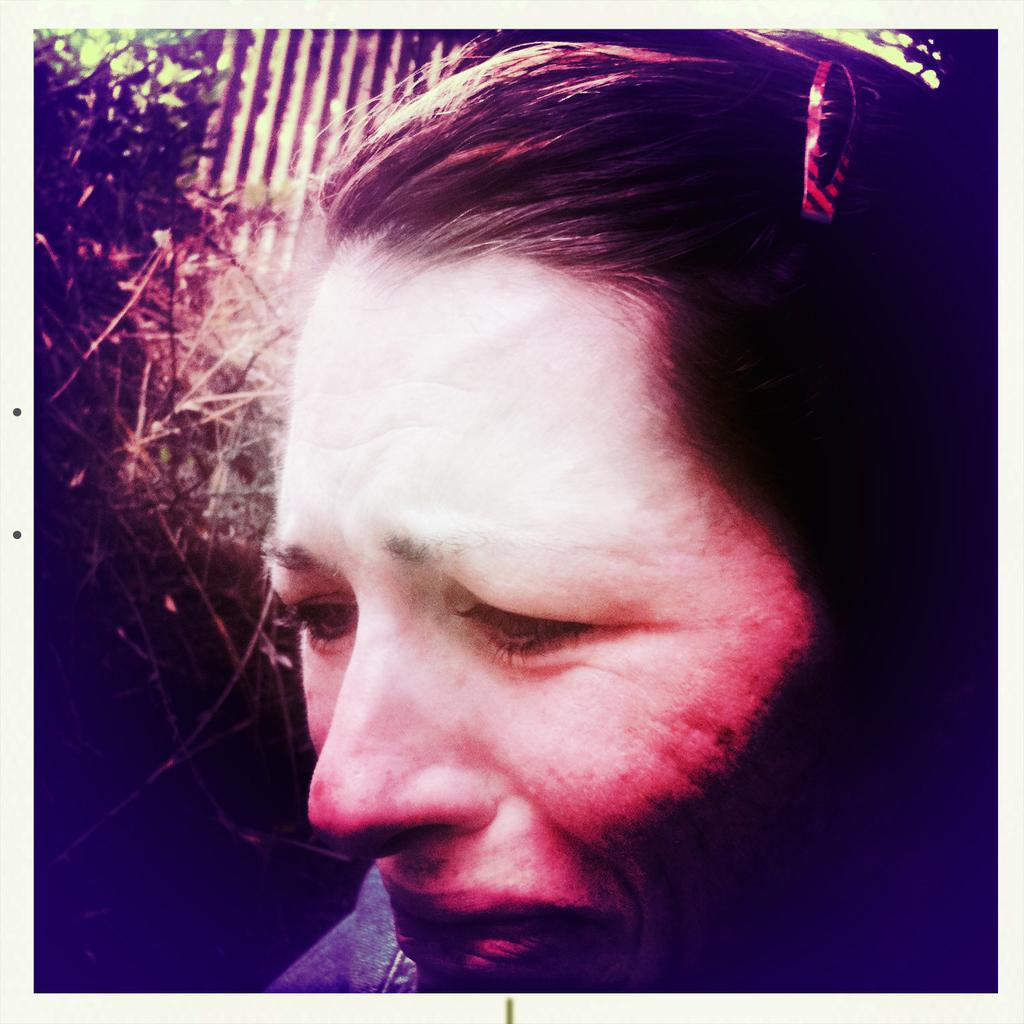What type of vegetation can be seen in the background of the image? There are: There are green leaves in the background of the image. What else is visible in the background of the image? There is an object in the background of the image. Can you describe the branches visible in the image? Yes, there are branches visible in the image. Who is present in the image? There is a person in the image. What is the person wearing in their hair? The person is wearing a hair clip. How does the person appear to be feeling in the image? The person appears to be crying. What type of popcorn is being offered to the crow in the image? There is no crow or popcorn present in the image. How does the person pull the branches in the image? There are no actions of pulling branches in the image; the branches are simply visible. 